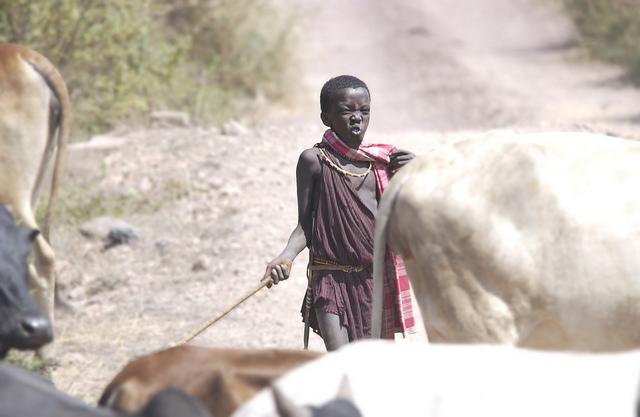What kind of animals are in there?
Quick response, please. Cows. Is this scene in America?
Concise answer only. No. What is the boy doing?
Quick response, please. Herding. 